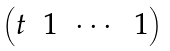<formula> <loc_0><loc_0><loc_500><loc_500>\begin{pmatrix} t & 1 & \cdots & 1 \end{pmatrix}</formula> 